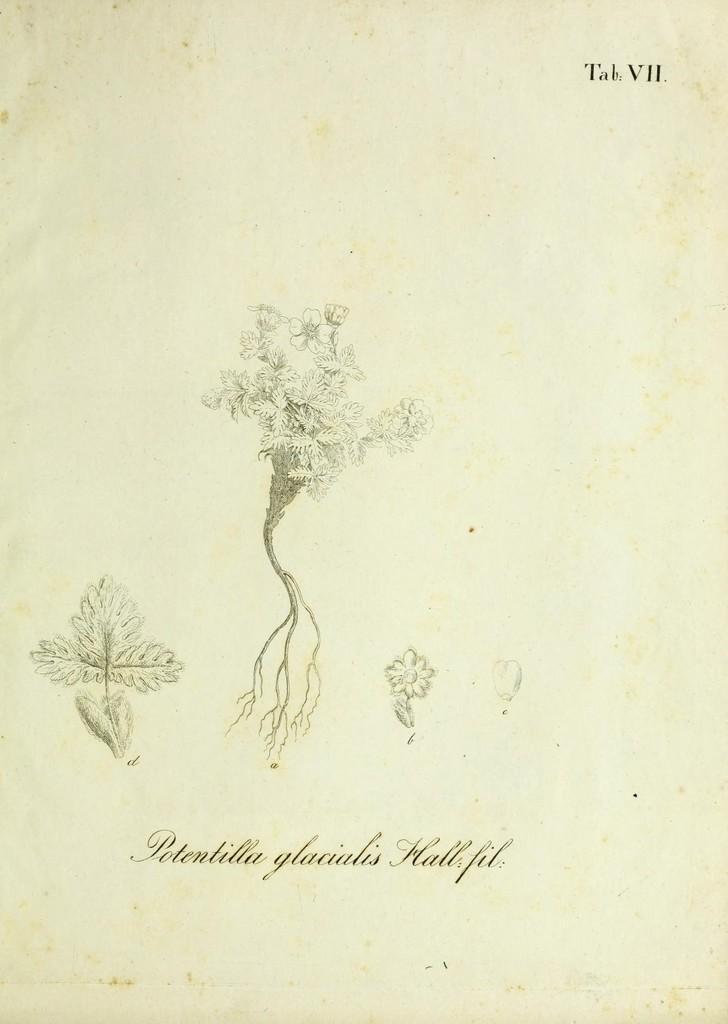Can you describe this image briefly? In this image there is a painting of a plant ,leaves ,and a flower in the middle of this image. There is some text written in the bottom of this image. 